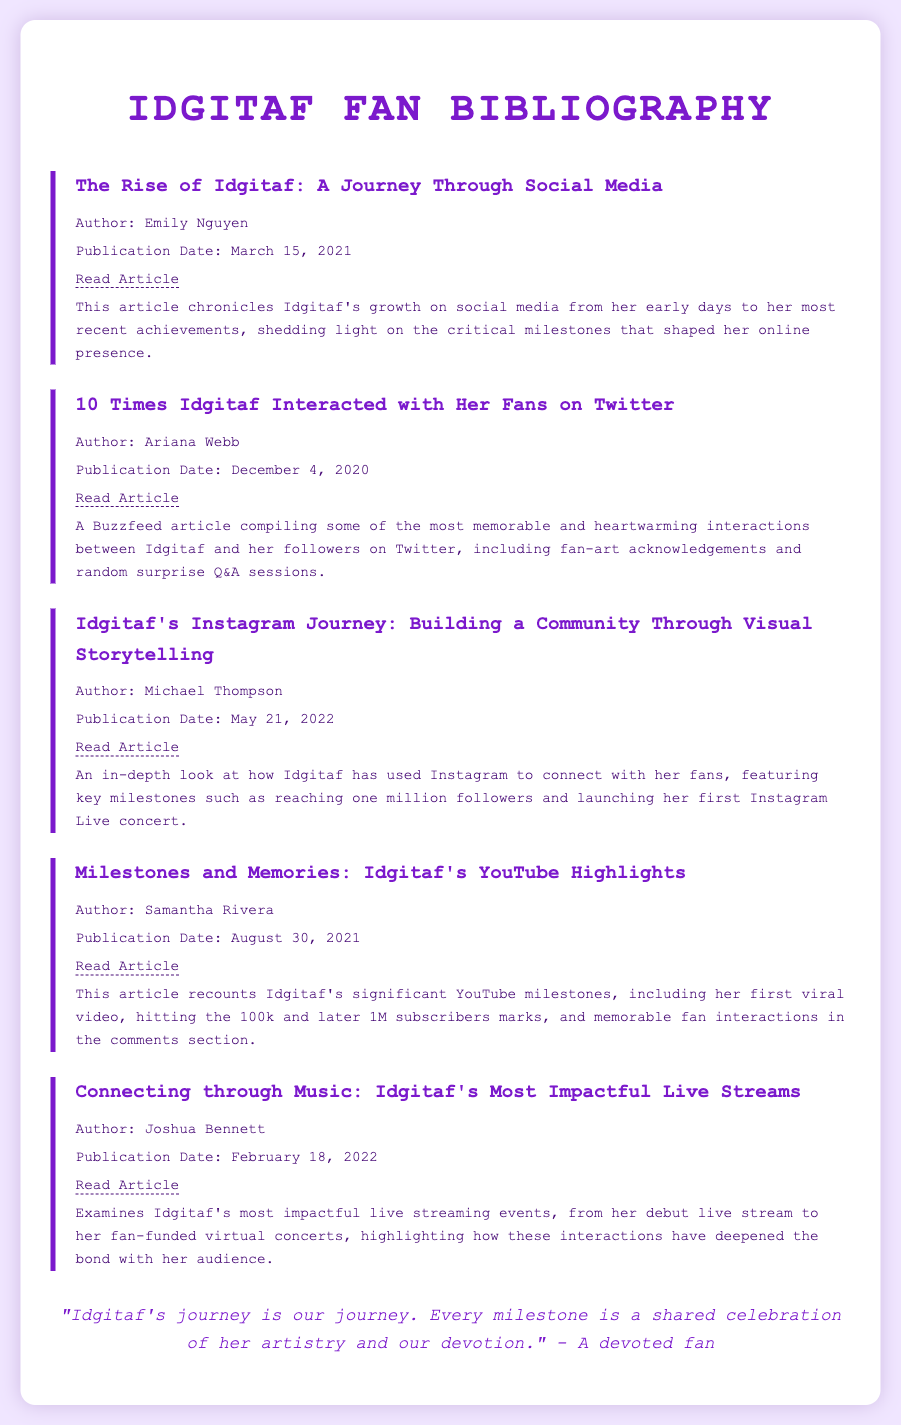What is the title of the first bibliography item? The title of the first bibliography item is listed at the top of the entry, which is "The Rise of Idgitaf: A Journey Through Social Media."
Answer: The Rise of Idgitaf: A Journey Through Social Media Who is the author of the article discussing Idgitaf's Instagram journey? The author's name is found in the bibliography item for the Instagram journey, which is "Michael Thompson."
Answer: Michael Thompson When was the article "10 Times Idgitaf Interacted with Her Fans on Twitter" published? The publication date for this article is indicated directly within the entry, which is "December 4, 2020."
Answer: December 4, 2020 What significant milestone does the Instagram journey article mention? Important details about key milestones are provided in the article, one of which is "reaching one million followers."
Answer: Reaching one million followers What is the common theme among the bibliography items listed? Each item focuses on different aspects of Idgitaf's social media presence and interactions with fans, showcasing how she has built her community.
Answer: Social media presence and interactions with fans 